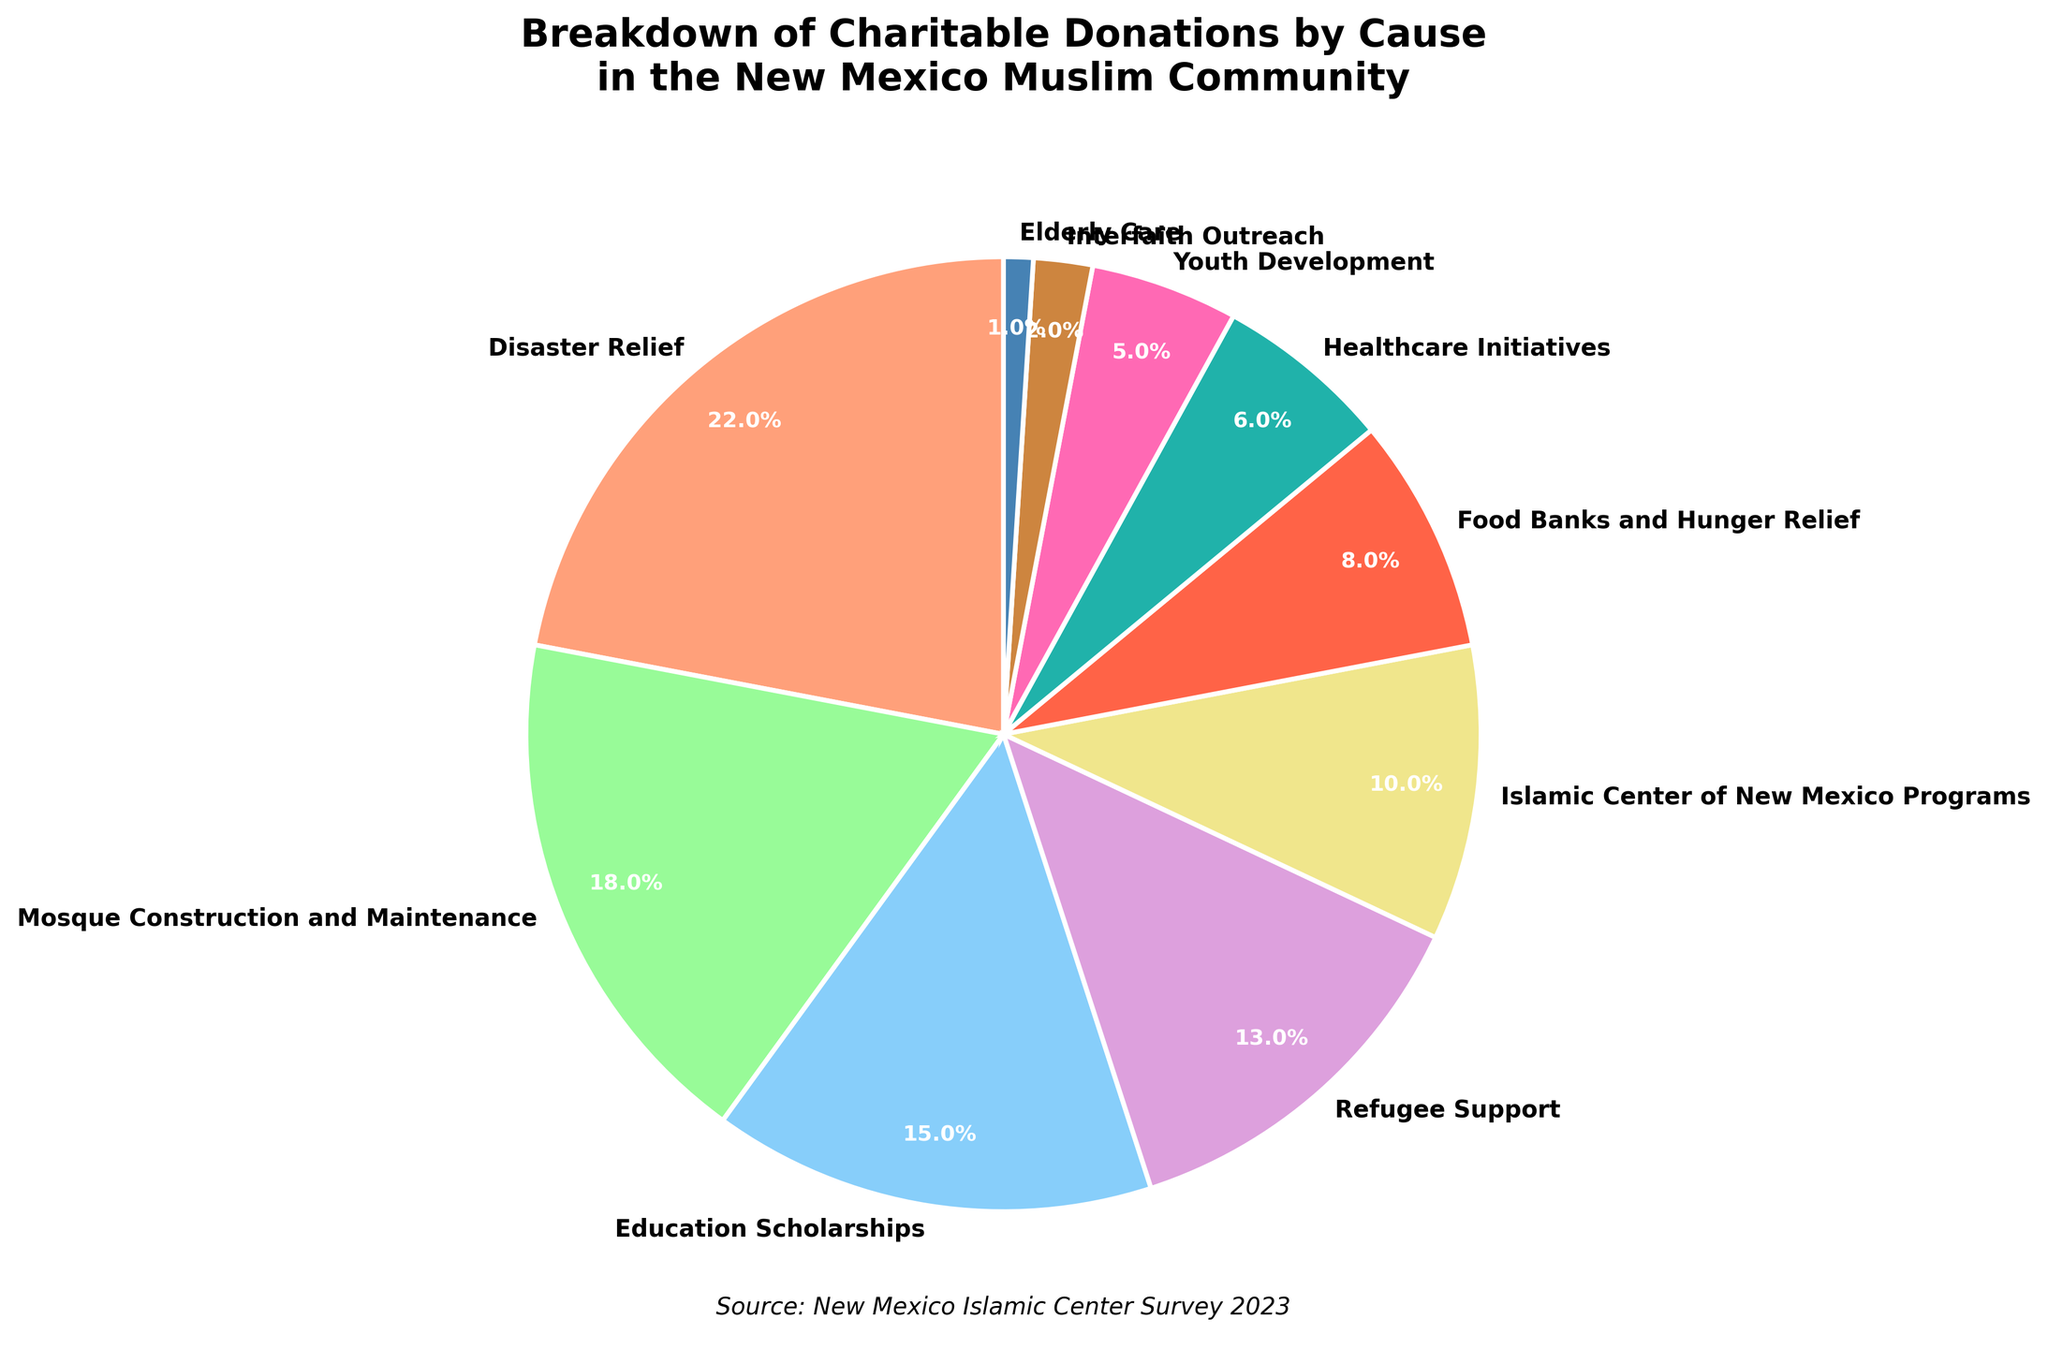What percentage of donations goes to Mosque Construction and Maintenance? Locate the segment labeled "Mosque Construction and Maintenance" in the pie chart. The percentage indicated is 18%.
Answer: 18% Which cause receives the highest percentage of charitable donations? Find the largest segment in the pie chart and identify its label. The largest segment is labeled "Disaster Relief," which accounts for 22%.
Answer: Disaster Relief What is the total percentage of donations directed towards Education Scholarships and Healthcare Initiatives combined? Locate the segments labeled "Education Scholarships" and "Healthcare Initiatives". Sum their percentages: 15% + 6% = 21%.
Answer: 21% Does Interfaith Outreach receive more donations than Youth Development? Locate the segments for "Interfaith Outreach" and "Youth Development" and compare their percentages. "Interfaith Outreach" receives 2% while "Youth Development" receives 5%. Therefore, Youth Development receives more.
Answer: No What is the percentage difference between donations for Refugee Support and Food Banks and Hunger Relief? Locate the segments labeled "Refugee Support" and "Food Banks and Hunger Relief". Calculate the difference in their percentages: 13% - 8% = 5%.
Answer: 5% Which causes together account for more than 40% of the total donations? Identify segments whose combined percentages exceed 40%. "Disaster Relief" (22%) and "Mosque Construction and Maintenance" (18%) collectively account for 40%. Any additional cause will push it over the threshold. Adding "Education Scholarships" (15%) leads to a combined 55%. Thus, Disaster Relief, Mosque Construction and Maintenance, and Education Scholarships combined account for more than 40%.
Answer: Disaster Relief, Mosque Construction and Maintenance, Education Scholarships Which segment represents the least percentage of charitable donations and what is its percentage? Find the smallest segment in the pie chart and identify its label. The smallest segment is labeled "Elderly Care," which accounts for 1%.
Answer: Elderly Care, 1% Are donations for Islamic Center of New Mexico Programs more than those for Healthcare Initiatives? Locate the segments labeled "Islamic Center of New Mexico Programs" and "Healthcare Initiatives," then compare their percentages. The former is 10% and the latter is 6%. Therefore, donations for Islamic Center of New Mexico Programs are more.
Answer: Yes What percentage of donations go to Youth Development when compared to Food Banks and Hunger Relief? Locate the segments labeled "Youth Development" and "Food Banks and Hunger Relief" and compute the ratio: Youth Development (5%) divided by Food Banks and Hunger Relief (8%) equals 5% / 8% = 0.625. The percentage is thus 62.5%.
Answer: 62.5% How many segments in the pie chart have a percentage greater than or equal to 10%? Count the segments with percentages 10% or higher. The segments are "Disaster Relief" (22%), "Mosque Construction and Maintenance" (18%), "Education Scholarships" (15%), "Refugee Support" (13%), and "Islamic Center of New Mexico Programs" (10%). There are 5 such segments.
Answer: 5 